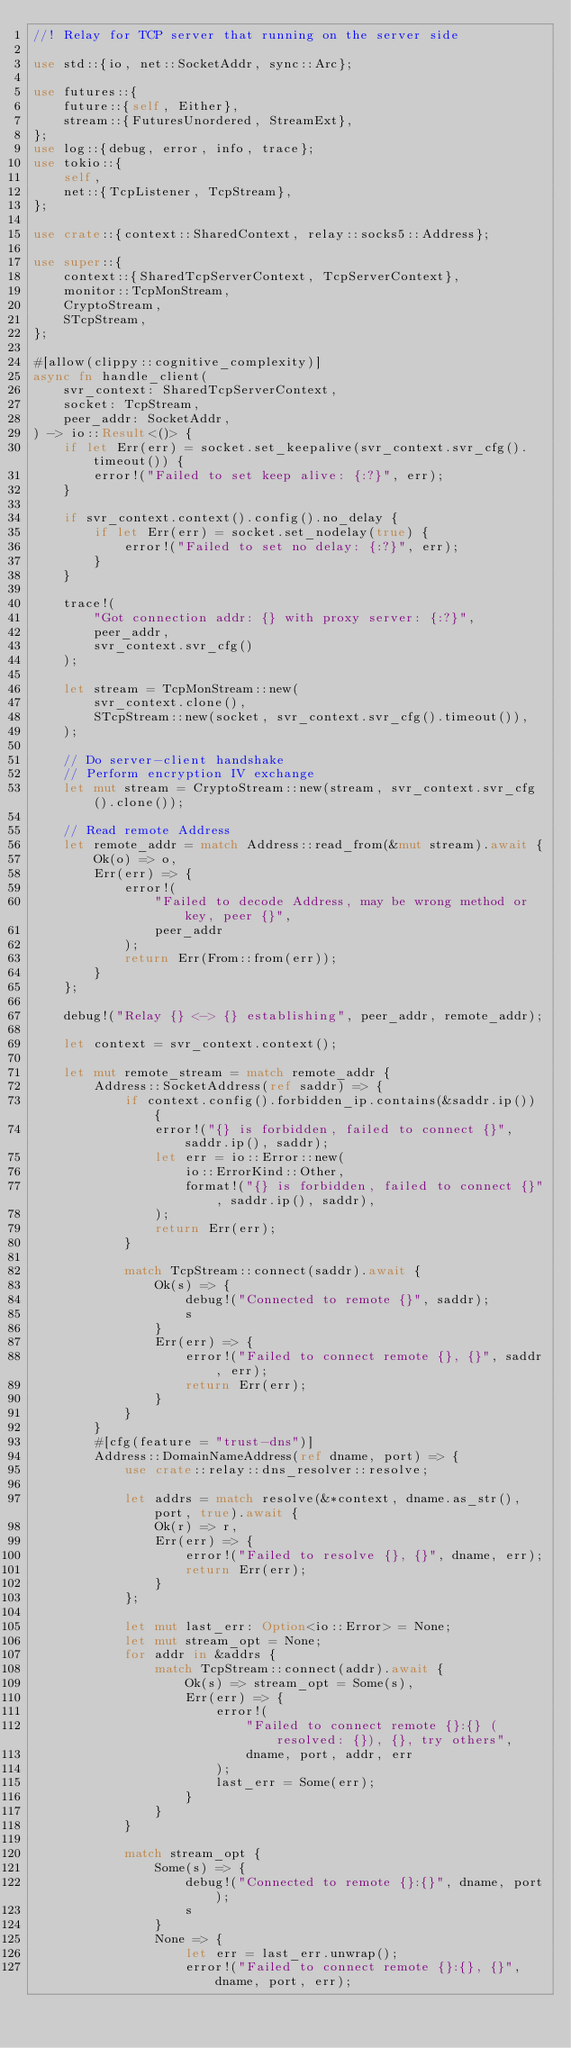Convert code to text. <code><loc_0><loc_0><loc_500><loc_500><_Rust_>//! Relay for TCP server that running on the server side

use std::{io, net::SocketAddr, sync::Arc};

use futures::{
    future::{self, Either},
    stream::{FuturesUnordered, StreamExt},
};
use log::{debug, error, info, trace};
use tokio::{
    self,
    net::{TcpListener, TcpStream},
};

use crate::{context::SharedContext, relay::socks5::Address};

use super::{
    context::{SharedTcpServerContext, TcpServerContext},
    monitor::TcpMonStream,
    CryptoStream,
    STcpStream,
};

#[allow(clippy::cognitive_complexity)]
async fn handle_client(
    svr_context: SharedTcpServerContext,
    socket: TcpStream,
    peer_addr: SocketAddr,
) -> io::Result<()> {
    if let Err(err) = socket.set_keepalive(svr_context.svr_cfg().timeout()) {
        error!("Failed to set keep alive: {:?}", err);
    }

    if svr_context.context().config().no_delay {
        if let Err(err) = socket.set_nodelay(true) {
            error!("Failed to set no delay: {:?}", err);
        }
    }

    trace!(
        "Got connection addr: {} with proxy server: {:?}",
        peer_addr,
        svr_context.svr_cfg()
    );

    let stream = TcpMonStream::new(
        svr_context.clone(),
        STcpStream::new(socket, svr_context.svr_cfg().timeout()),
    );

    // Do server-client handshake
    // Perform encryption IV exchange
    let mut stream = CryptoStream::new(stream, svr_context.svr_cfg().clone());

    // Read remote Address
    let remote_addr = match Address::read_from(&mut stream).await {
        Ok(o) => o,
        Err(err) => {
            error!(
                "Failed to decode Address, may be wrong method or key, peer {}",
                peer_addr
            );
            return Err(From::from(err));
        }
    };

    debug!("Relay {} <-> {} establishing", peer_addr, remote_addr);

    let context = svr_context.context();

    let mut remote_stream = match remote_addr {
        Address::SocketAddress(ref saddr) => {
            if context.config().forbidden_ip.contains(&saddr.ip()) {
                error!("{} is forbidden, failed to connect {}", saddr.ip(), saddr);
                let err = io::Error::new(
                    io::ErrorKind::Other,
                    format!("{} is forbidden, failed to connect {}", saddr.ip(), saddr),
                );
                return Err(err);
            }

            match TcpStream::connect(saddr).await {
                Ok(s) => {
                    debug!("Connected to remote {}", saddr);
                    s
                }
                Err(err) => {
                    error!("Failed to connect remote {}, {}", saddr, err);
                    return Err(err);
                }
            }
        }
        #[cfg(feature = "trust-dns")]
        Address::DomainNameAddress(ref dname, port) => {
            use crate::relay::dns_resolver::resolve;

            let addrs = match resolve(&*context, dname.as_str(), port, true).await {
                Ok(r) => r,
                Err(err) => {
                    error!("Failed to resolve {}, {}", dname, err);
                    return Err(err);
                }
            };

            let mut last_err: Option<io::Error> = None;
            let mut stream_opt = None;
            for addr in &addrs {
                match TcpStream::connect(addr).await {
                    Ok(s) => stream_opt = Some(s),
                    Err(err) => {
                        error!(
                            "Failed to connect remote {}:{} (resolved: {}), {}, try others",
                            dname, port, addr, err
                        );
                        last_err = Some(err);
                    }
                }
            }

            match stream_opt {
                Some(s) => {
                    debug!("Connected to remote {}:{}", dname, port);
                    s
                }
                None => {
                    let err = last_err.unwrap();
                    error!("Failed to connect remote {}:{}, {}", dname, port, err);</code> 